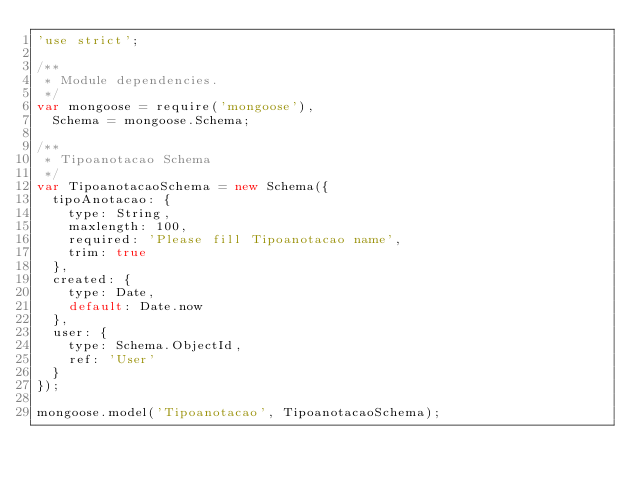<code> <loc_0><loc_0><loc_500><loc_500><_JavaScript_>'use strict';

/**
 * Module dependencies.
 */
var mongoose = require('mongoose'),
  Schema = mongoose.Schema;

/**
 * Tipoanotacao Schema
 */
var TipoanotacaoSchema = new Schema({
  tipoAnotacao: {
    type: String,
    maxlength: 100,
    required: 'Please fill Tipoanotacao name',
    trim: true
  },
  created: {
    type: Date,
    default: Date.now
  },
  user: {
    type: Schema.ObjectId,
    ref: 'User'
  }
});

mongoose.model('Tipoanotacao', TipoanotacaoSchema);
</code> 